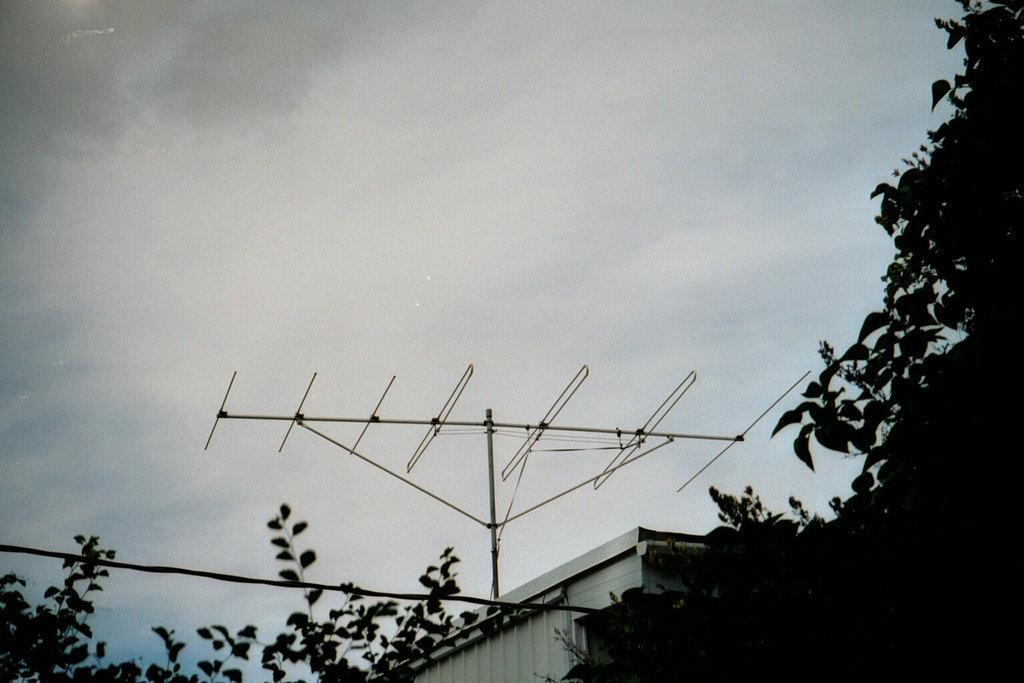Please provide a concise description of this image. In image we can see antenna on the top of the building and the background is the sky. 